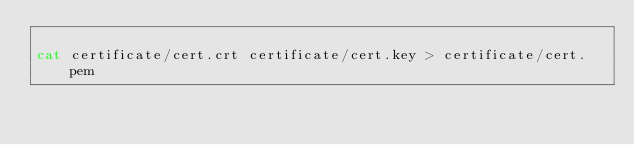Convert code to text. <code><loc_0><loc_0><loc_500><loc_500><_Bash_>
cat certificate/cert.crt certificate/cert.key > certificate/cert.pem
</code> 